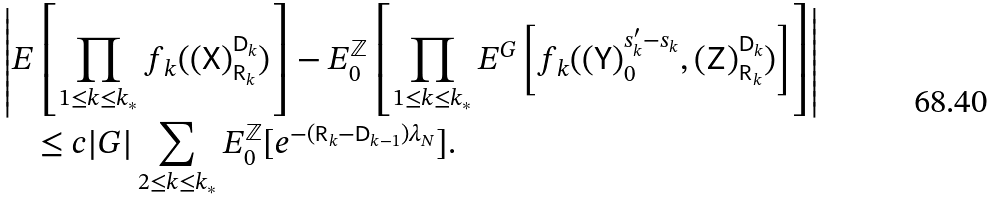<formula> <loc_0><loc_0><loc_500><loc_500>& \left | E \left [ \prod _ { 1 \leq k \leq k _ { * } } f _ { k } ( ( { \mathsf X } ) _ { { \mathsf R } _ { k } } ^ { { \mathsf D } _ { k } } ) \right ] - E ^ { \mathbb { Z } } _ { 0 } \left [ \prod _ { 1 \leq k \leq k _ { * } } E ^ { G } \left [ f _ { k } ( ( { \mathsf Y } ) _ { 0 } ^ { s ^ { \prime } _ { k } - s _ { k } } , ( { \mathsf Z } ) _ { { \mathsf R } _ { k } } ^ { { \mathsf D } _ { k } } ) \right ] \right ] \right | \\ & \quad \leq c | G | \sum _ { 2 \leq k \leq k _ { * } } E ^ { \mathbb { Z } } _ { 0 } [ e ^ { - ( { \mathsf R } _ { k } - { \mathsf D } _ { k - 1 } ) \lambda _ { N } } ] .</formula> 